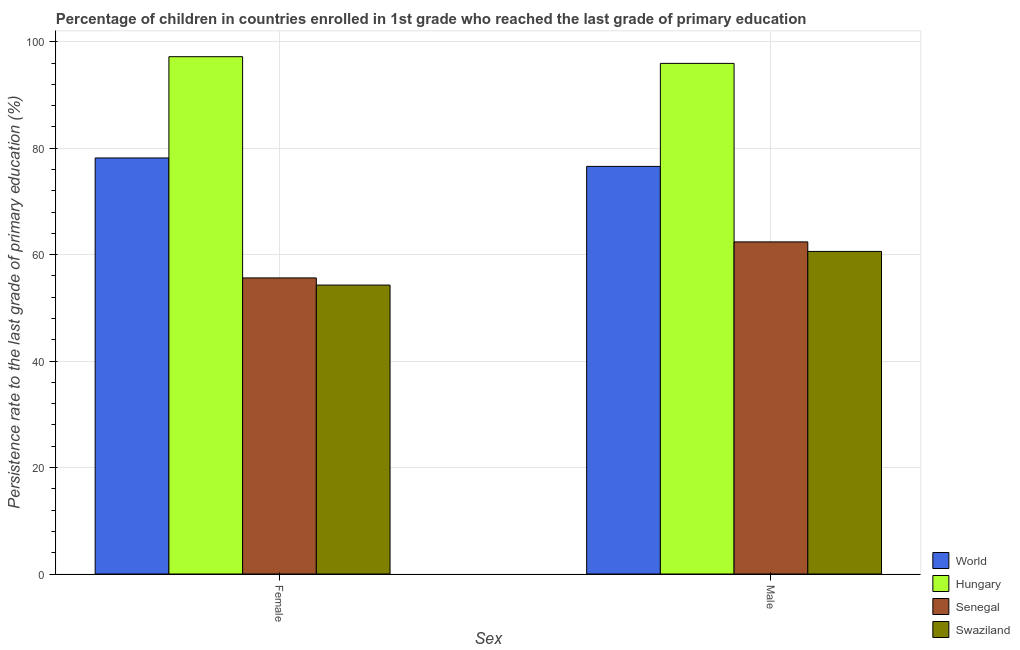How many different coloured bars are there?
Offer a terse response. 4. How many groups of bars are there?
Provide a short and direct response. 2. Are the number of bars on each tick of the X-axis equal?
Your answer should be compact. Yes. How many bars are there on the 1st tick from the right?
Provide a short and direct response. 4. What is the persistence rate of male students in Senegal?
Keep it short and to the point. 62.4. Across all countries, what is the maximum persistence rate of female students?
Keep it short and to the point. 97.19. Across all countries, what is the minimum persistence rate of male students?
Your answer should be very brief. 60.61. In which country was the persistence rate of male students maximum?
Your answer should be compact. Hungary. In which country was the persistence rate of male students minimum?
Your response must be concise. Swaziland. What is the total persistence rate of male students in the graph?
Provide a short and direct response. 295.52. What is the difference between the persistence rate of female students in Swaziland and that in Senegal?
Your answer should be compact. -1.34. What is the difference between the persistence rate of female students in World and the persistence rate of male students in Senegal?
Ensure brevity in your answer.  15.77. What is the average persistence rate of female students per country?
Ensure brevity in your answer.  71.32. What is the difference between the persistence rate of male students and persistence rate of female students in Swaziland?
Provide a succinct answer. 6.32. What is the ratio of the persistence rate of male students in World to that in Senegal?
Offer a very short reply. 1.23. Is the persistence rate of male students in Senegal less than that in World?
Keep it short and to the point. Yes. What does the 3rd bar from the left in Male represents?
Your answer should be compact. Senegal. What does the 1st bar from the right in Female represents?
Make the answer very short. Swaziland. How many bars are there?
Make the answer very short. 8. Does the graph contain grids?
Your answer should be compact. Yes. Where does the legend appear in the graph?
Keep it short and to the point. Bottom right. What is the title of the graph?
Provide a short and direct response. Percentage of children in countries enrolled in 1st grade who reached the last grade of primary education. What is the label or title of the X-axis?
Provide a short and direct response. Sex. What is the label or title of the Y-axis?
Keep it short and to the point. Persistence rate to the last grade of primary education (%). What is the Persistence rate to the last grade of primary education (%) in World in Female?
Ensure brevity in your answer.  78.17. What is the Persistence rate to the last grade of primary education (%) of Hungary in Female?
Give a very brief answer. 97.19. What is the Persistence rate to the last grade of primary education (%) of Senegal in Female?
Provide a succinct answer. 55.63. What is the Persistence rate to the last grade of primary education (%) in Swaziland in Female?
Your response must be concise. 54.29. What is the Persistence rate to the last grade of primary education (%) of World in Male?
Ensure brevity in your answer.  76.58. What is the Persistence rate to the last grade of primary education (%) of Hungary in Male?
Provide a short and direct response. 95.94. What is the Persistence rate to the last grade of primary education (%) of Senegal in Male?
Give a very brief answer. 62.4. What is the Persistence rate to the last grade of primary education (%) of Swaziland in Male?
Provide a succinct answer. 60.61. Across all Sex, what is the maximum Persistence rate to the last grade of primary education (%) of World?
Provide a succinct answer. 78.17. Across all Sex, what is the maximum Persistence rate to the last grade of primary education (%) of Hungary?
Provide a short and direct response. 97.19. Across all Sex, what is the maximum Persistence rate to the last grade of primary education (%) in Senegal?
Your response must be concise. 62.4. Across all Sex, what is the maximum Persistence rate to the last grade of primary education (%) of Swaziland?
Ensure brevity in your answer.  60.61. Across all Sex, what is the minimum Persistence rate to the last grade of primary education (%) in World?
Provide a short and direct response. 76.58. Across all Sex, what is the minimum Persistence rate to the last grade of primary education (%) in Hungary?
Offer a very short reply. 95.94. Across all Sex, what is the minimum Persistence rate to the last grade of primary education (%) in Senegal?
Ensure brevity in your answer.  55.63. Across all Sex, what is the minimum Persistence rate to the last grade of primary education (%) in Swaziland?
Offer a very short reply. 54.29. What is the total Persistence rate to the last grade of primary education (%) in World in the graph?
Ensure brevity in your answer.  154.75. What is the total Persistence rate to the last grade of primary education (%) in Hungary in the graph?
Provide a short and direct response. 193.13. What is the total Persistence rate to the last grade of primary education (%) in Senegal in the graph?
Ensure brevity in your answer.  118.02. What is the total Persistence rate to the last grade of primary education (%) in Swaziland in the graph?
Offer a very short reply. 114.89. What is the difference between the Persistence rate to the last grade of primary education (%) of World in Female and that in Male?
Provide a succinct answer. 1.59. What is the difference between the Persistence rate to the last grade of primary education (%) of Hungary in Female and that in Male?
Your answer should be compact. 1.26. What is the difference between the Persistence rate to the last grade of primary education (%) of Senegal in Female and that in Male?
Make the answer very short. -6.77. What is the difference between the Persistence rate to the last grade of primary education (%) of Swaziland in Female and that in Male?
Keep it short and to the point. -6.32. What is the difference between the Persistence rate to the last grade of primary education (%) in World in Female and the Persistence rate to the last grade of primary education (%) in Hungary in Male?
Your answer should be compact. -17.77. What is the difference between the Persistence rate to the last grade of primary education (%) of World in Female and the Persistence rate to the last grade of primary education (%) of Senegal in Male?
Offer a terse response. 15.77. What is the difference between the Persistence rate to the last grade of primary education (%) in World in Female and the Persistence rate to the last grade of primary education (%) in Swaziland in Male?
Make the answer very short. 17.56. What is the difference between the Persistence rate to the last grade of primary education (%) in Hungary in Female and the Persistence rate to the last grade of primary education (%) in Senegal in Male?
Provide a short and direct response. 34.8. What is the difference between the Persistence rate to the last grade of primary education (%) of Hungary in Female and the Persistence rate to the last grade of primary education (%) of Swaziland in Male?
Ensure brevity in your answer.  36.59. What is the difference between the Persistence rate to the last grade of primary education (%) of Senegal in Female and the Persistence rate to the last grade of primary education (%) of Swaziland in Male?
Provide a succinct answer. -4.98. What is the average Persistence rate to the last grade of primary education (%) of World per Sex?
Offer a terse response. 77.38. What is the average Persistence rate to the last grade of primary education (%) in Hungary per Sex?
Make the answer very short. 96.57. What is the average Persistence rate to the last grade of primary education (%) of Senegal per Sex?
Provide a short and direct response. 59.01. What is the average Persistence rate to the last grade of primary education (%) in Swaziland per Sex?
Give a very brief answer. 57.45. What is the difference between the Persistence rate to the last grade of primary education (%) in World and Persistence rate to the last grade of primary education (%) in Hungary in Female?
Your answer should be compact. -19.03. What is the difference between the Persistence rate to the last grade of primary education (%) in World and Persistence rate to the last grade of primary education (%) in Senegal in Female?
Give a very brief answer. 22.54. What is the difference between the Persistence rate to the last grade of primary education (%) of World and Persistence rate to the last grade of primary education (%) of Swaziland in Female?
Offer a very short reply. 23.88. What is the difference between the Persistence rate to the last grade of primary education (%) in Hungary and Persistence rate to the last grade of primary education (%) in Senegal in Female?
Your response must be concise. 41.57. What is the difference between the Persistence rate to the last grade of primary education (%) in Hungary and Persistence rate to the last grade of primary education (%) in Swaziland in Female?
Keep it short and to the point. 42.91. What is the difference between the Persistence rate to the last grade of primary education (%) in Senegal and Persistence rate to the last grade of primary education (%) in Swaziland in Female?
Your answer should be very brief. 1.34. What is the difference between the Persistence rate to the last grade of primary education (%) of World and Persistence rate to the last grade of primary education (%) of Hungary in Male?
Provide a short and direct response. -19.36. What is the difference between the Persistence rate to the last grade of primary education (%) in World and Persistence rate to the last grade of primary education (%) in Senegal in Male?
Keep it short and to the point. 14.18. What is the difference between the Persistence rate to the last grade of primary education (%) of World and Persistence rate to the last grade of primary education (%) of Swaziland in Male?
Offer a terse response. 15.97. What is the difference between the Persistence rate to the last grade of primary education (%) in Hungary and Persistence rate to the last grade of primary education (%) in Senegal in Male?
Your response must be concise. 33.54. What is the difference between the Persistence rate to the last grade of primary education (%) in Hungary and Persistence rate to the last grade of primary education (%) in Swaziland in Male?
Offer a very short reply. 35.33. What is the difference between the Persistence rate to the last grade of primary education (%) of Senegal and Persistence rate to the last grade of primary education (%) of Swaziland in Male?
Provide a succinct answer. 1.79. What is the ratio of the Persistence rate to the last grade of primary education (%) of World in Female to that in Male?
Make the answer very short. 1.02. What is the ratio of the Persistence rate to the last grade of primary education (%) of Hungary in Female to that in Male?
Make the answer very short. 1.01. What is the ratio of the Persistence rate to the last grade of primary education (%) of Senegal in Female to that in Male?
Your answer should be very brief. 0.89. What is the ratio of the Persistence rate to the last grade of primary education (%) of Swaziland in Female to that in Male?
Make the answer very short. 0.9. What is the difference between the highest and the second highest Persistence rate to the last grade of primary education (%) of World?
Give a very brief answer. 1.59. What is the difference between the highest and the second highest Persistence rate to the last grade of primary education (%) of Hungary?
Your answer should be compact. 1.26. What is the difference between the highest and the second highest Persistence rate to the last grade of primary education (%) of Senegal?
Provide a succinct answer. 6.77. What is the difference between the highest and the second highest Persistence rate to the last grade of primary education (%) of Swaziland?
Give a very brief answer. 6.32. What is the difference between the highest and the lowest Persistence rate to the last grade of primary education (%) of World?
Your answer should be very brief. 1.59. What is the difference between the highest and the lowest Persistence rate to the last grade of primary education (%) of Hungary?
Make the answer very short. 1.26. What is the difference between the highest and the lowest Persistence rate to the last grade of primary education (%) in Senegal?
Ensure brevity in your answer.  6.77. What is the difference between the highest and the lowest Persistence rate to the last grade of primary education (%) of Swaziland?
Provide a short and direct response. 6.32. 